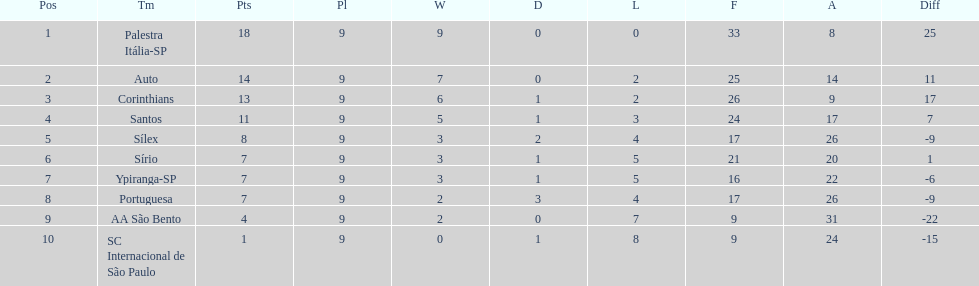In the 1926 brazilian football season, how many teams managed to score over 10 points? 4. 